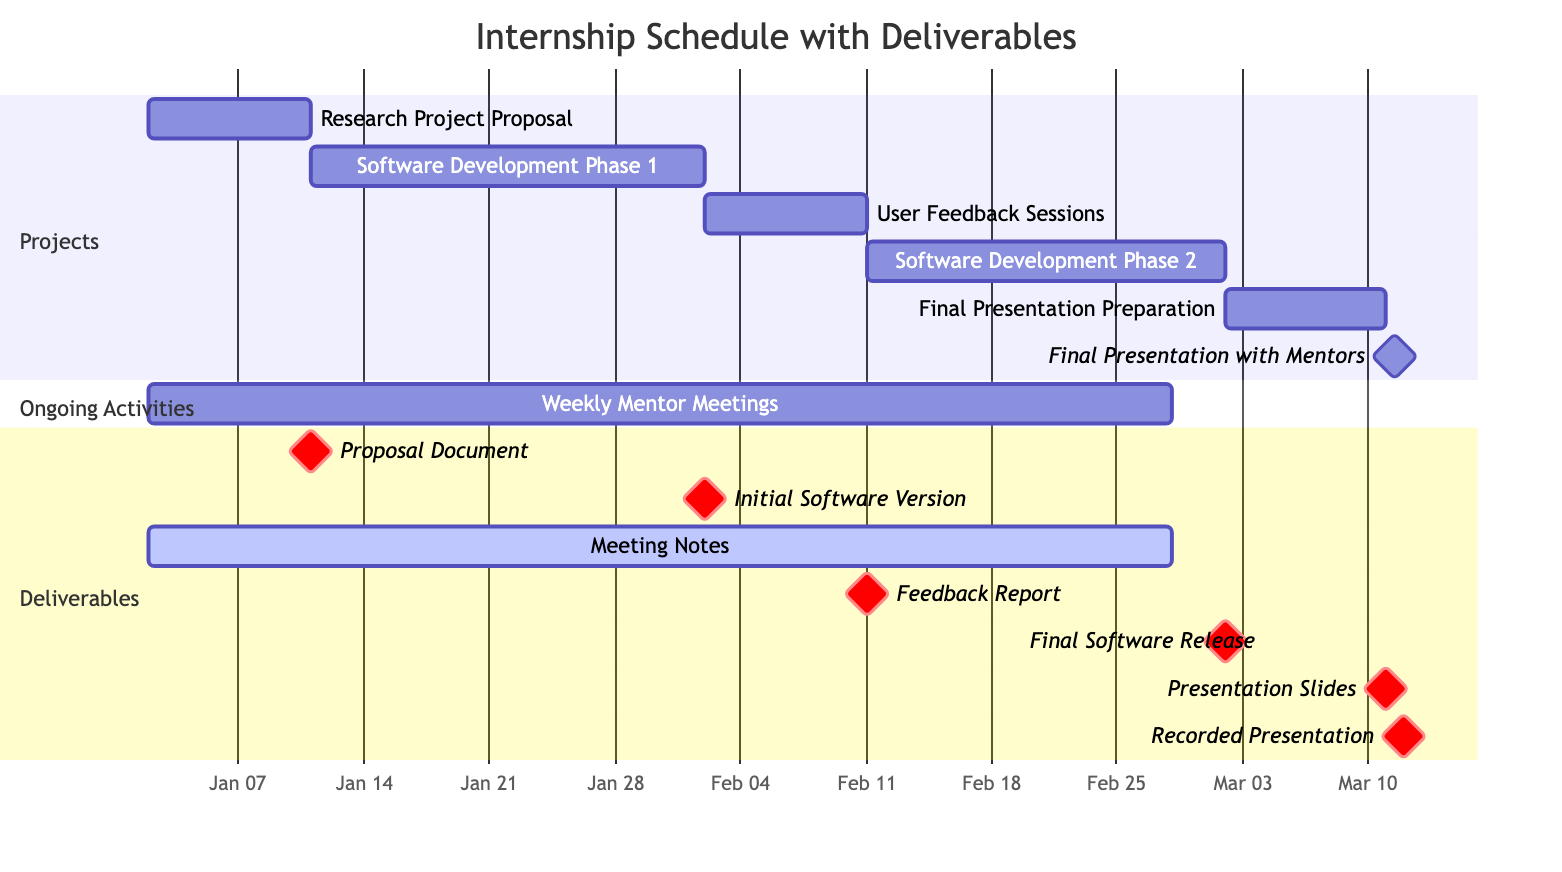What is the duration of the Research Project Proposal? The Research Project Proposal starts on January 2, 2024, and ends on January 10, 2024. Counting the days, this is a total of 9 days.
Answer: 9 days How many ongoing activities are shown in the Gantt chart? There is one ongoing activity depicted in the Gantt chart: Weekly Mentor Meetings. Therefore, there is only 1 ongoing activity.
Answer: 1 What is the deliverable for the Software Development Phase 1? The Software Development Phase 1 has the deliverable specified as Initial Software Version. This can be found under the Deliverables section related to the task.
Answer: Initial Software Version When does the User Feedback Sessions start? The User Feedback Sessions task is shown to start on February 2, 2024, directly indicated on the Gantt chart.
Answer: February 2, 2024 Which deliverable is due after the Final Presentation Preparation? Following the Final Presentation Preparation, the deliverable due is the Recorded Presentation, as it appears as a milestone right after the task completion.
Answer: Recorded Presentation What will be produced after the Software Development Phase 2? The deliverable following the Software Development Phase 2 is Final Software Release. It can be easily traced in the Deliverables section related to this task.
Answer: Final Software Release How many total deliverables are indicated in the Gantt chart? By counting the listed items in the Deliverables section, there are a total of 7 deliverables mentioned in the Gantt chart.
Answer: 7 What is the end date for the Software Development Phase 1? The end date for the Software Development Phase 1 is February 1, 2024, which is specified directly in the Gantt chart timeline for that task.
Answer: February 1, 2024 What is the earliest task based on the start date? The earliest task, based on the start date, is the Research Project Proposal, which commences on January 2, 2024. This is clearly shown as the first task in the timeline.
Answer: Research Project Proposal 